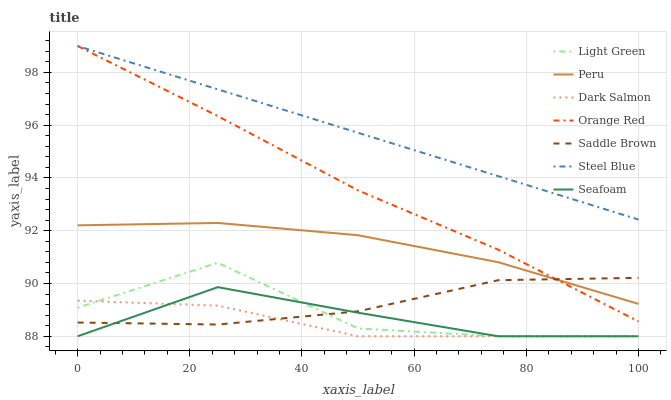Does Dark Salmon have the minimum area under the curve?
Answer yes or no. Yes. Does Steel Blue have the maximum area under the curve?
Answer yes or no. Yes. Does Light Green have the minimum area under the curve?
Answer yes or no. No. Does Light Green have the maximum area under the curve?
Answer yes or no. No. Is Steel Blue the smoothest?
Answer yes or no. Yes. Is Light Green the roughest?
Answer yes or no. Yes. Is Light Green the smoothest?
Answer yes or no. No. Is Steel Blue the roughest?
Answer yes or no. No. Does Seafoam have the lowest value?
Answer yes or no. Yes. Does Steel Blue have the lowest value?
Answer yes or no. No. Does Orange Red have the highest value?
Answer yes or no. Yes. Does Light Green have the highest value?
Answer yes or no. No. Is Light Green less than Orange Red?
Answer yes or no. Yes. Is Steel Blue greater than Light Green?
Answer yes or no. Yes. Does Light Green intersect Saddle Brown?
Answer yes or no. Yes. Is Light Green less than Saddle Brown?
Answer yes or no. No. Is Light Green greater than Saddle Brown?
Answer yes or no. No. Does Light Green intersect Orange Red?
Answer yes or no. No. 